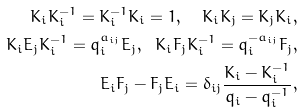<formula> <loc_0><loc_0><loc_500><loc_500>K _ { i } K _ { i } ^ { - 1 } = K _ { i } ^ { - 1 } K _ { i } = 1 , \ \ K _ { i } K _ { j } = K _ { j } K _ { i } , \\ K _ { i } E _ { j } K _ { i } ^ { - 1 } = q _ { i } ^ { a _ { i j } } E _ { j } , \ \ K _ { i } F _ { j } K _ { i } ^ { - 1 } = q _ { i } ^ { - a _ { i j } } F _ { j } , \\ E _ { i } F _ { j } - F _ { j } E _ { i } = \delta _ { i j } \frac { K _ { i } - K _ { i } ^ { - 1 } } { q _ { i } - q _ { i } ^ { - 1 } } ,</formula> 